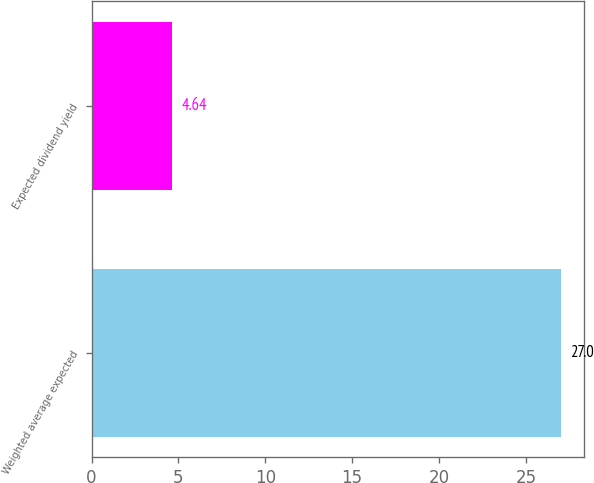Convert chart. <chart><loc_0><loc_0><loc_500><loc_500><bar_chart><fcel>Weighted average expected<fcel>Expected dividend yield<nl><fcel>27<fcel>4.64<nl></chart> 